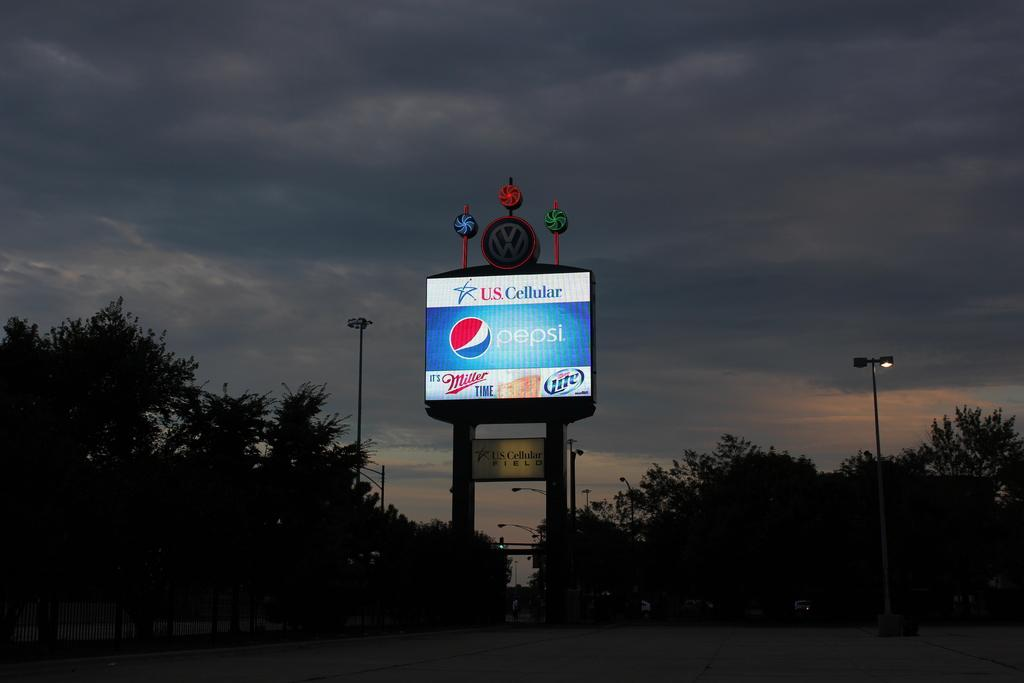<image>
Provide a brief description of the given image. A sunset behind a Volkswagen stadium with a Pepsi ad on it. 